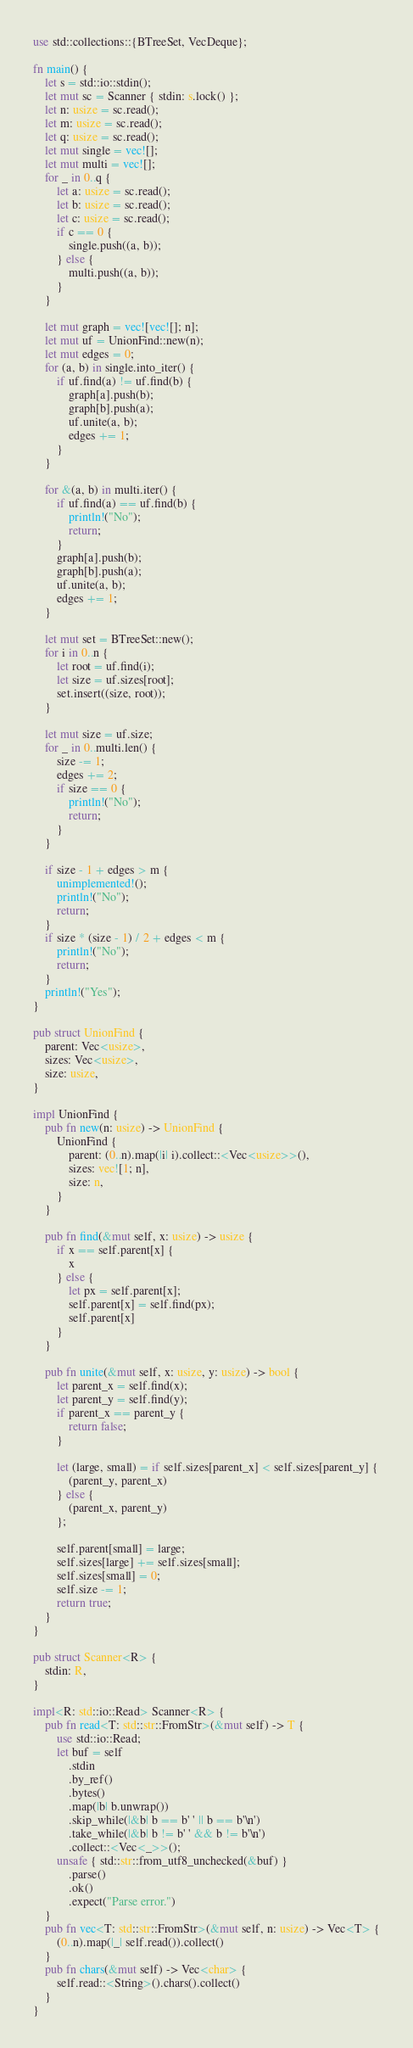Convert code to text. <code><loc_0><loc_0><loc_500><loc_500><_Rust_>use std::collections::{BTreeSet, VecDeque};

fn main() {
    let s = std::io::stdin();
    let mut sc = Scanner { stdin: s.lock() };
    let n: usize = sc.read();
    let m: usize = sc.read();
    let q: usize = sc.read();
    let mut single = vec![];
    let mut multi = vec![];
    for _ in 0..q {
        let a: usize = sc.read();
        let b: usize = sc.read();
        let c: usize = sc.read();
        if c == 0 {
            single.push((a, b));
        } else {
            multi.push((a, b));
        }
    }

    let mut graph = vec![vec![]; n];
    let mut uf = UnionFind::new(n);
    let mut edges = 0;
    for (a, b) in single.into_iter() {
        if uf.find(a) != uf.find(b) {
            graph[a].push(b);
            graph[b].push(a);
            uf.unite(a, b);
            edges += 1;
        }
    }

    for &(a, b) in multi.iter() {
        if uf.find(a) == uf.find(b) {
            println!("No");
            return;
        }
        graph[a].push(b);
        graph[b].push(a);
        uf.unite(a, b);
        edges += 1;
    }

    let mut set = BTreeSet::new();
    for i in 0..n {
        let root = uf.find(i);
        let size = uf.sizes[root];
        set.insert((size, root));
    }

    let mut size = uf.size;
    for _ in 0..multi.len() {
        size -= 1;
        edges += 2;
        if size == 0 {
            println!("No");
            return;
        }
    }

    if size - 1 + edges > m {
        unimplemented!();
        println!("No");
        return;
    }
    if size * (size - 1) / 2 + edges < m {
        println!("No");
        return;
    }
    println!("Yes");
}

pub struct UnionFind {
    parent: Vec<usize>,
    sizes: Vec<usize>,
    size: usize,
}

impl UnionFind {
    pub fn new(n: usize) -> UnionFind {
        UnionFind {
            parent: (0..n).map(|i| i).collect::<Vec<usize>>(),
            sizes: vec![1; n],
            size: n,
        }
    }

    pub fn find(&mut self, x: usize) -> usize {
        if x == self.parent[x] {
            x
        } else {
            let px = self.parent[x];
            self.parent[x] = self.find(px);
            self.parent[x]
        }
    }

    pub fn unite(&mut self, x: usize, y: usize) -> bool {
        let parent_x = self.find(x);
        let parent_y = self.find(y);
        if parent_x == parent_y {
            return false;
        }

        let (large, small) = if self.sizes[parent_x] < self.sizes[parent_y] {
            (parent_y, parent_x)
        } else {
            (parent_x, parent_y)
        };

        self.parent[small] = large;
        self.sizes[large] += self.sizes[small];
        self.sizes[small] = 0;
        self.size -= 1;
        return true;
    }
}

pub struct Scanner<R> {
    stdin: R,
}

impl<R: std::io::Read> Scanner<R> {
    pub fn read<T: std::str::FromStr>(&mut self) -> T {
        use std::io::Read;
        let buf = self
            .stdin
            .by_ref()
            .bytes()
            .map(|b| b.unwrap())
            .skip_while(|&b| b == b' ' || b == b'\n')
            .take_while(|&b| b != b' ' && b != b'\n')
            .collect::<Vec<_>>();
        unsafe { std::str::from_utf8_unchecked(&buf) }
            .parse()
            .ok()
            .expect("Parse error.")
    }
    pub fn vec<T: std::str::FromStr>(&mut self, n: usize) -> Vec<T> {
        (0..n).map(|_| self.read()).collect()
    }
    pub fn chars(&mut self) -> Vec<char> {
        self.read::<String>().chars().collect()
    }
}
</code> 